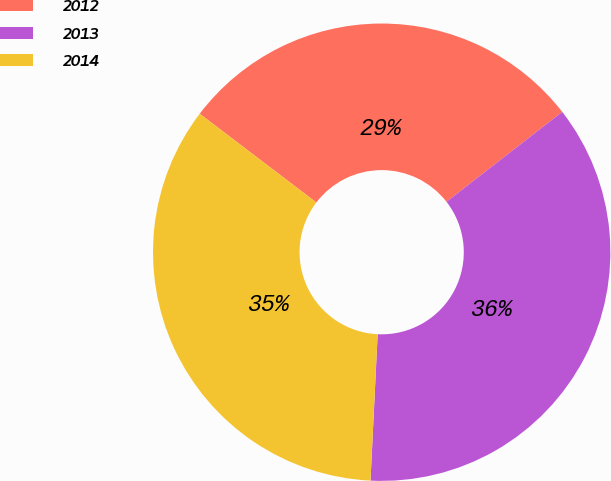Convert chart to OTSL. <chart><loc_0><loc_0><loc_500><loc_500><pie_chart><fcel>2012<fcel>2013<fcel>2014<nl><fcel>29.13%<fcel>36.29%<fcel>34.57%<nl></chart> 